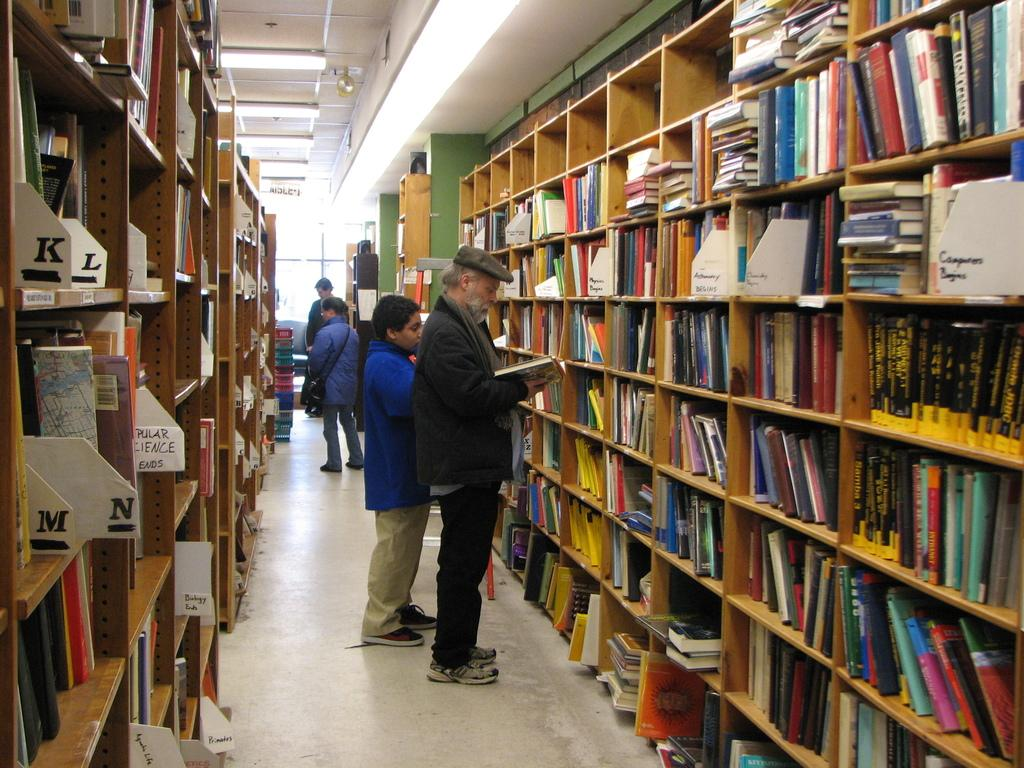<image>
Offer a succinct explanation of the picture presented. Man reading a book inside of a library with a letter K section sticking out. 